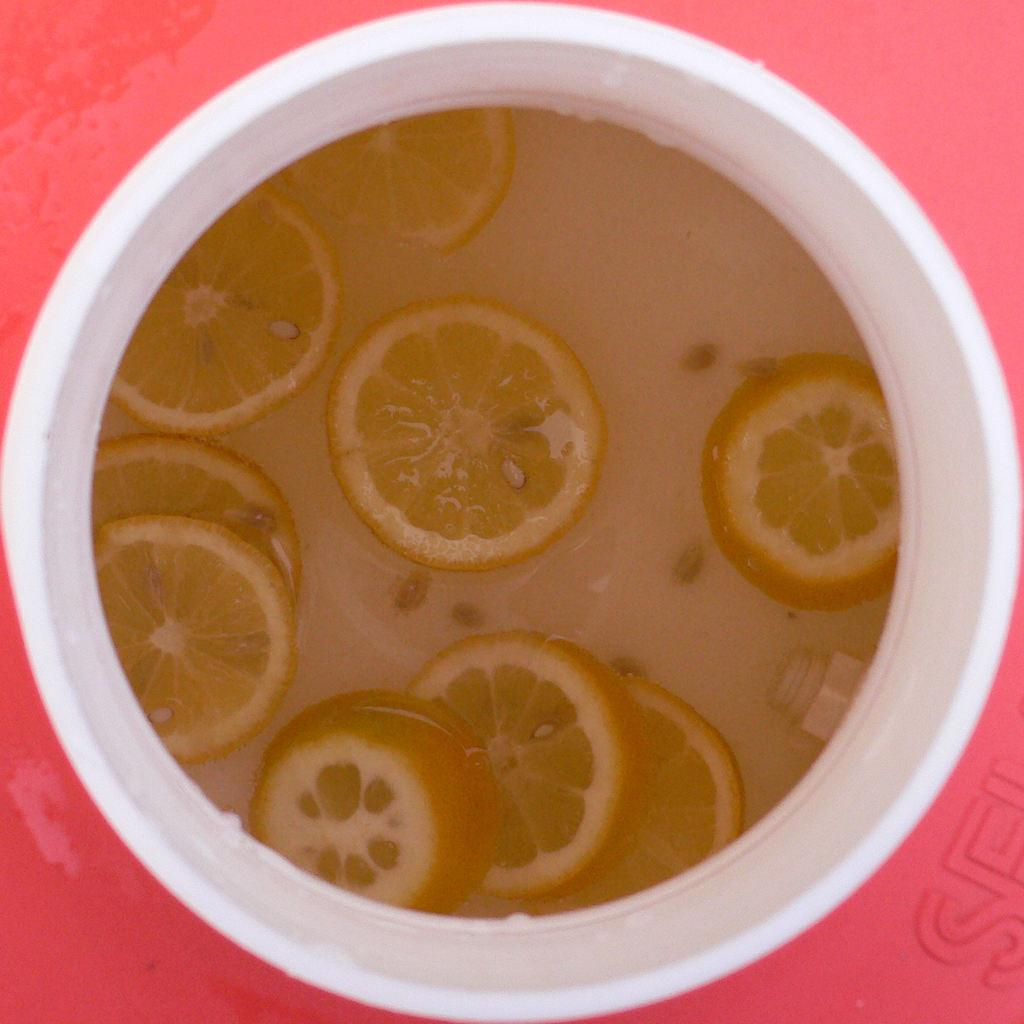What is the color of the object on the red surface in the image? The object on the red surface is white. What is inside the white object? There are lemon slices inside the white object. Is there anything else inside the white object besides the lemon slices? Yes, there is an unspecified thing inside the white object along with the lemon slices. What type of religious symbol can be seen inside the white object? There is no religious symbol present inside the white object; it contains lemon slices and an unspecified thing. 